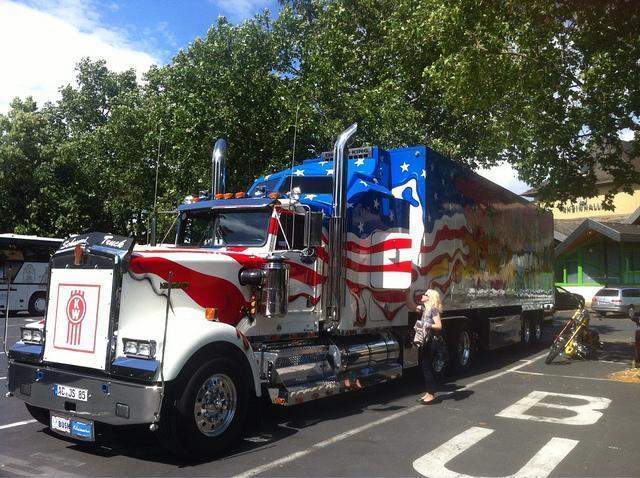How many cats are there?
Give a very brief answer. 0. 